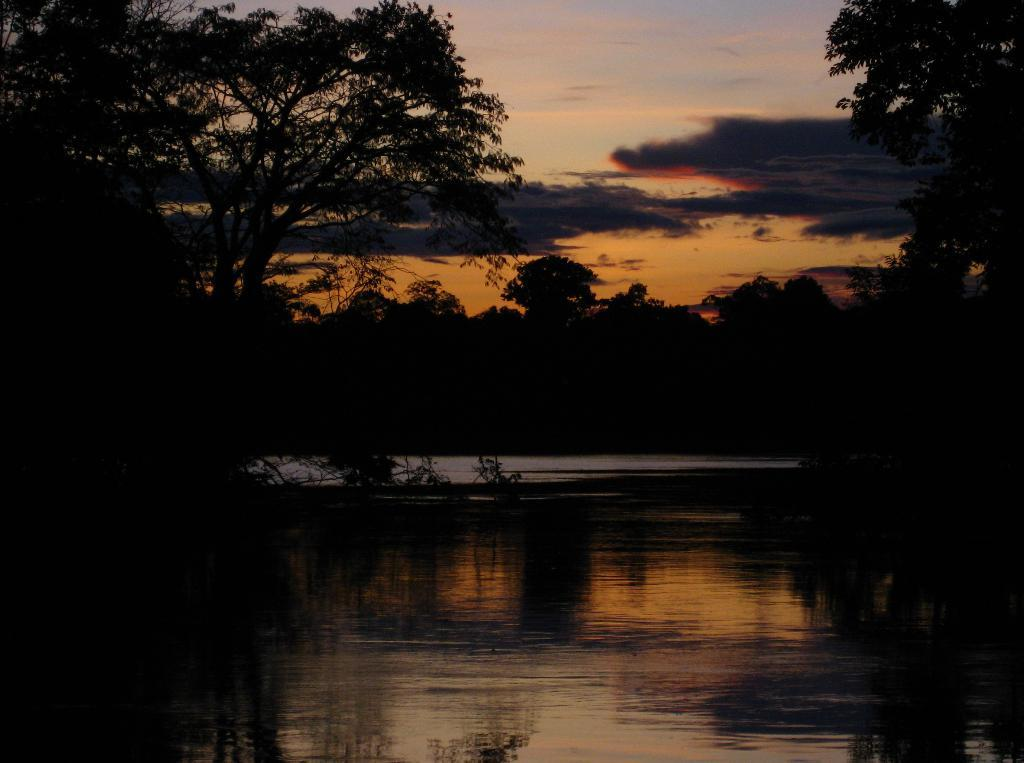What is present on both sides of the image? There is water on either side of the image. What can be found near the water? There are plants and trees near the water. What is visible in the background of the image? There are trees and the sky visible in the background of the image. What can be seen in the sky? Clouds are present in the sky. Can you see a giraffe using a quilt to take a breath in the image? There is no giraffe or quilt present in the image, and therefore no such activity can be observed. 